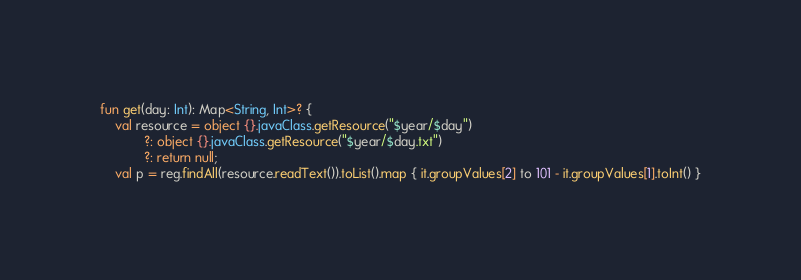<code> <loc_0><loc_0><loc_500><loc_500><_Kotlin_>
fun get(day: Int): Map<String, Int>? {
    val resource = object {}.javaClass.getResource("$year/$day")
            ?: object {}.javaClass.getResource("$year/$day.txt")
            ?: return null;
    val p = reg.findAll(resource.readText()).toList().map { it.groupValues[2] to 101 - it.groupValues[1].toInt() }</code> 